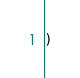<code> <loc_0><loc_0><loc_500><loc_500><_SQL_>)
</code> 